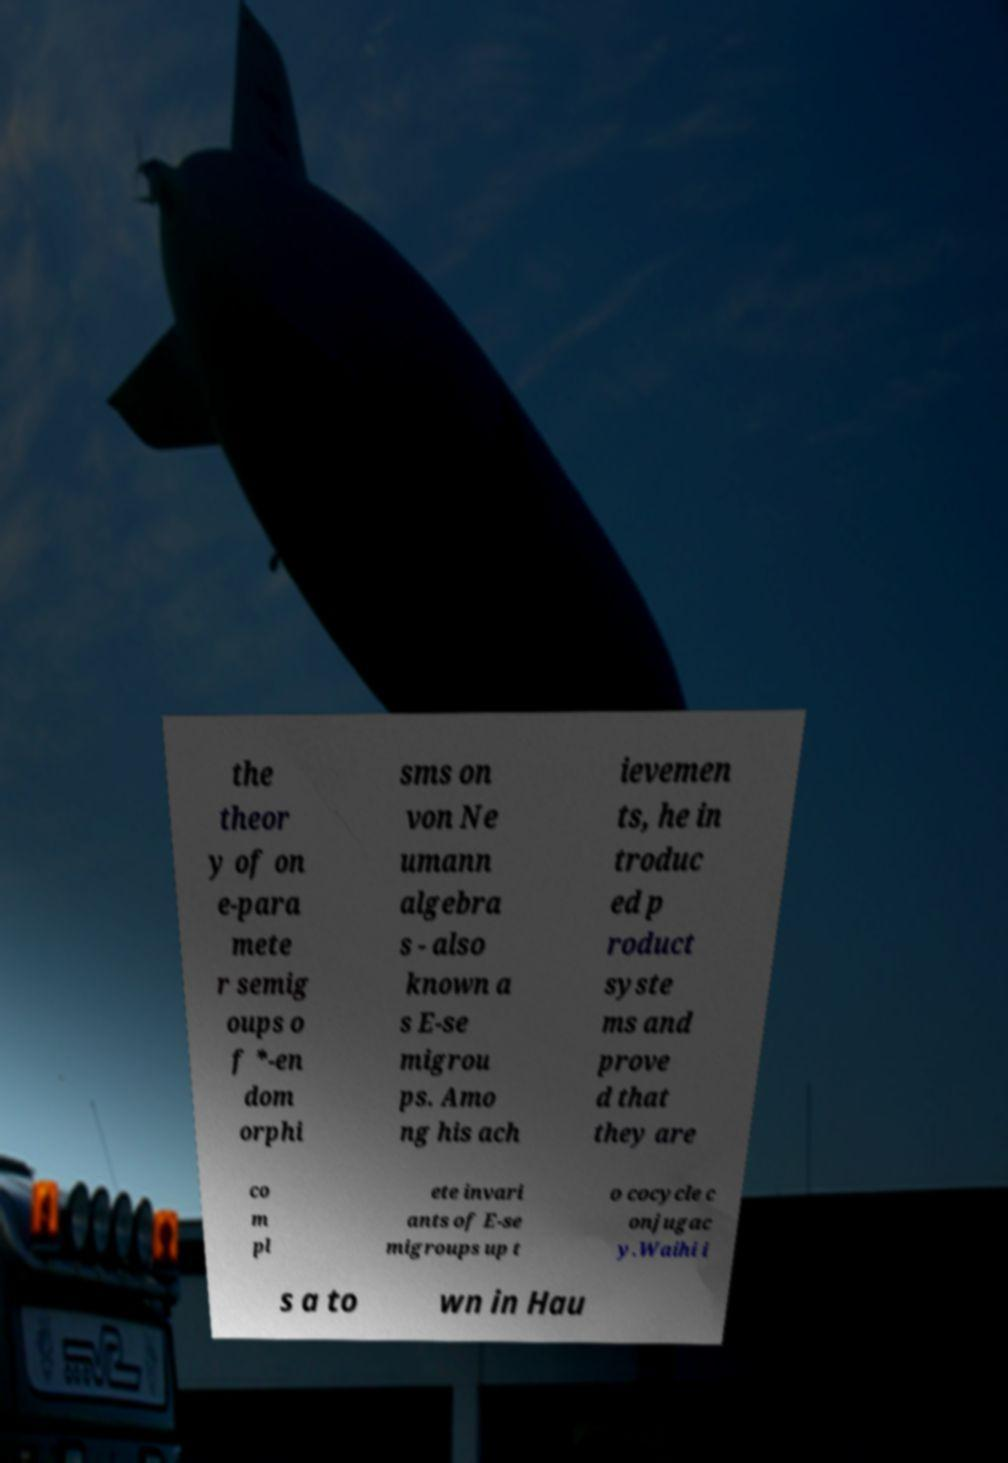Could you extract and type out the text from this image? the theor y of on e-para mete r semig oups o f *-en dom orphi sms on von Ne umann algebra s - also known a s E-se migrou ps. Amo ng his ach ievemen ts, he in troduc ed p roduct syste ms and prove d that they are co m pl ete invari ants of E-se migroups up t o cocycle c onjugac y.Waihi i s a to wn in Hau 